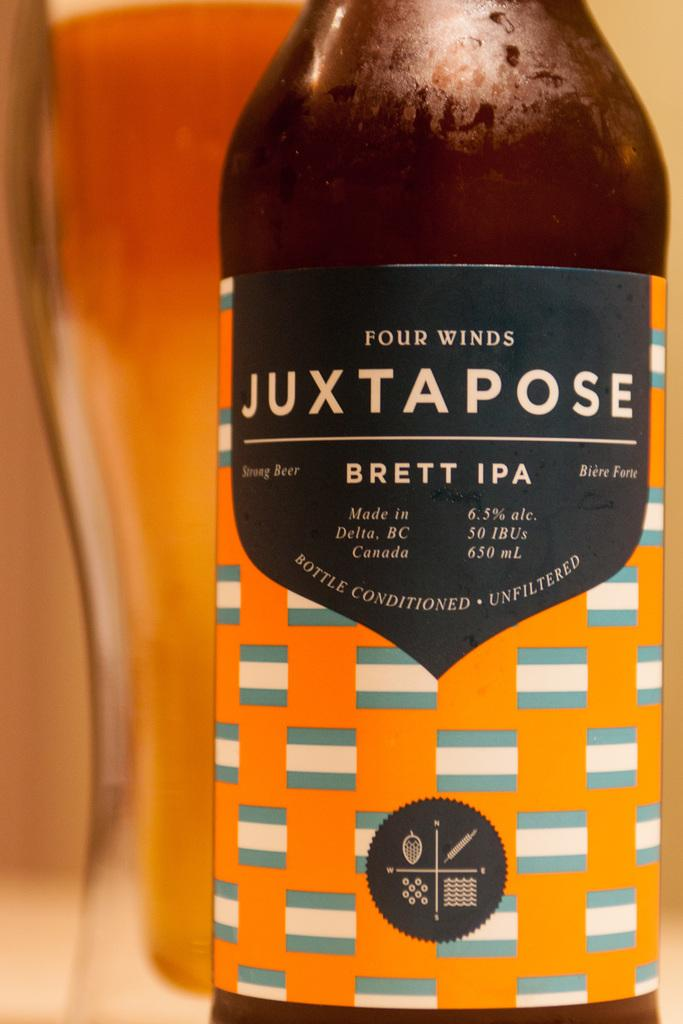<image>
Create a compact narrative representing the image presented. a bottle of four winds juxtapose brett ipa that says 'bottle conditioned. unfiltered.' 